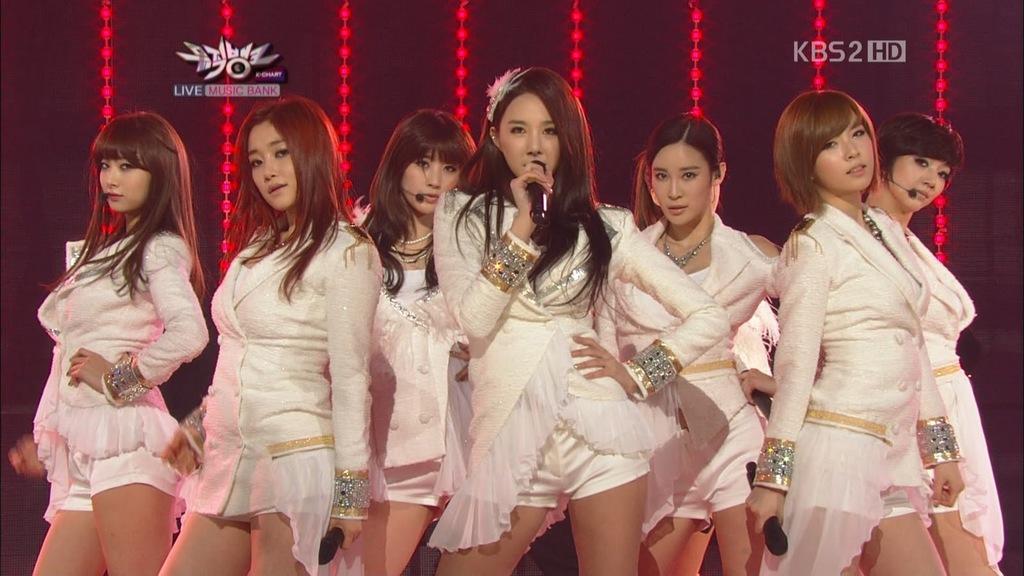In one or two sentences, can you explain what this image depicts? In this image I can see women standing, they are wearing white dresses and holding microphones. Lights are hanging at the back. 